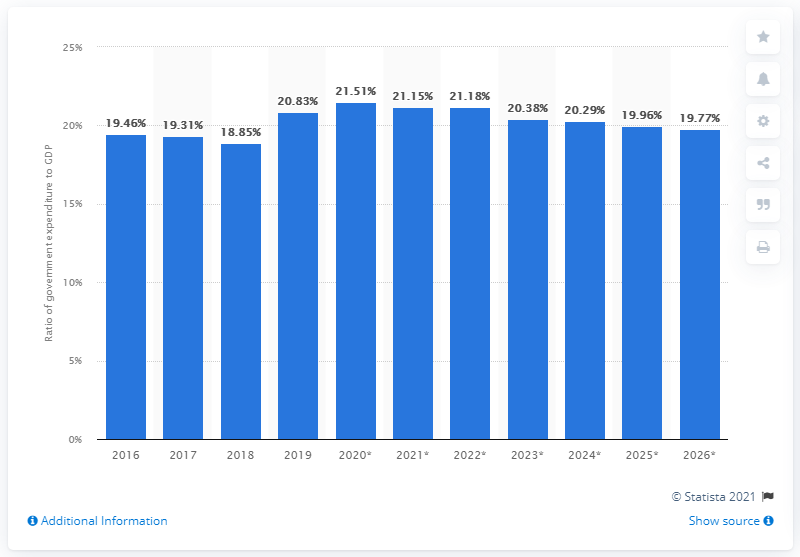What factors could explain the variation in government expenditure percentage in Sri Lanka as shown in the chart? Several factors can influence variations in government expenditure as a percentage of GDP. These may include policy changes, economic reforms, fluctuations in revenue or GDP growth rates, shifts in government priorities, responses to economic crises or natural disasters, and planned investments in infrastructure or social services. The chart suggests a peak around 2020 to 2021, which could be attributed to increased spending due to the global pandemic and subsequent recovery efforts. The gradual decline projected thereafter might reflect stabilization and a return to fiscal consolidation practices. 